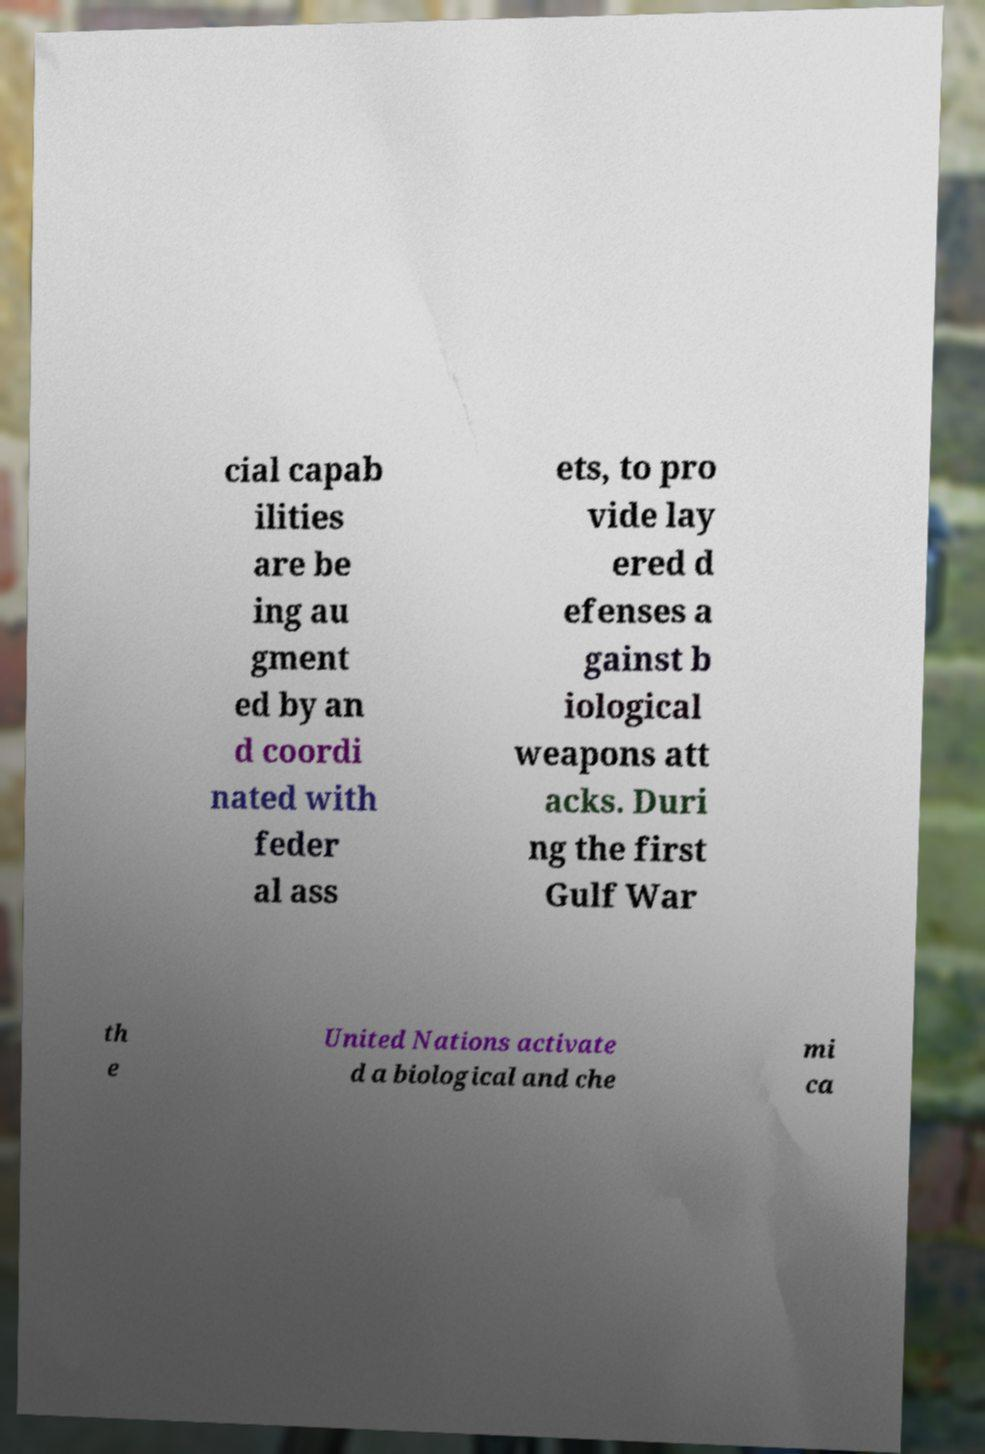Can you read and provide the text displayed in the image?This photo seems to have some interesting text. Can you extract and type it out for me? cial capab ilities are be ing au gment ed by an d coordi nated with feder al ass ets, to pro vide lay ered d efenses a gainst b iological weapons att acks. Duri ng the first Gulf War th e United Nations activate d a biological and che mi ca 